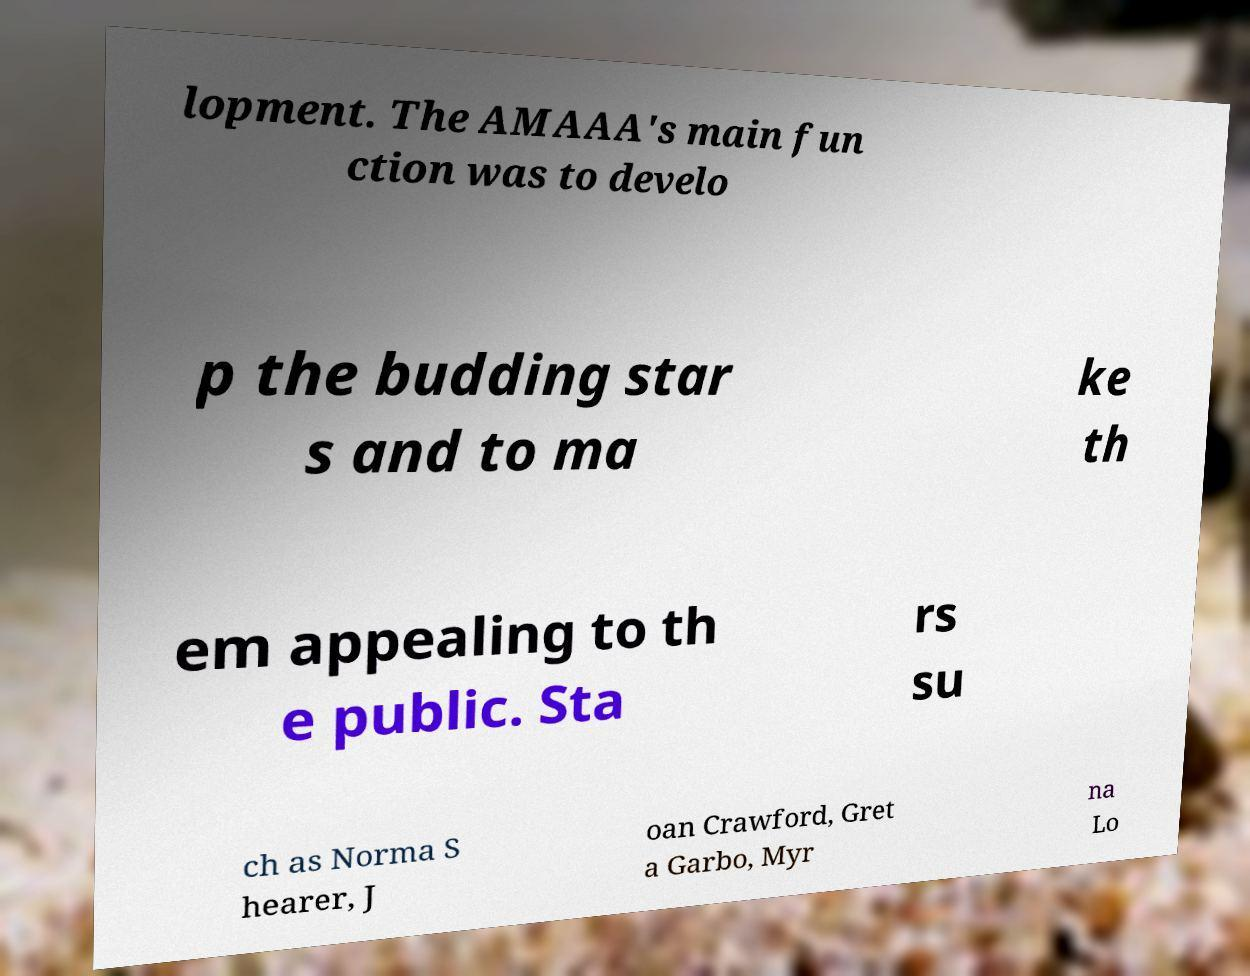For documentation purposes, I need the text within this image transcribed. Could you provide that? lopment. The AMAAA's main fun ction was to develo p the budding star s and to ma ke th em appealing to th e public. Sta rs su ch as Norma S hearer, J oan Crawford, Gret a Garbo, Myr na Lo 